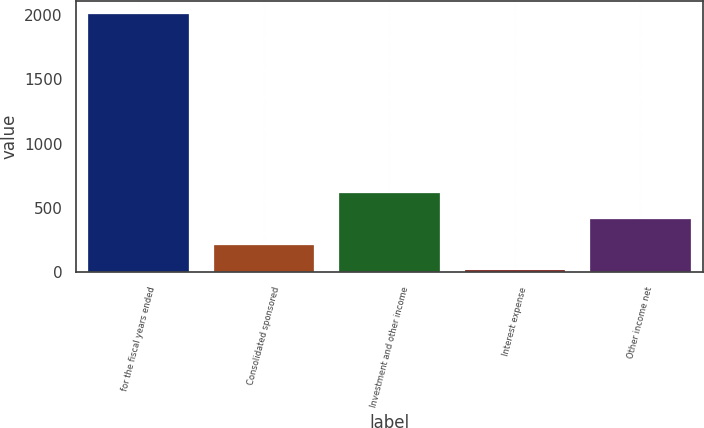Convert chart. <chart><loc_0><loc_0><loc_500><loc_500><bar_chart><fcel>for the fiscal years ended<fcel>Consolidated sponsored<fcel>Investment and other income<fcel>Interest expense<fcel>Other income net<nl><fcel>2008<fcel>215.02<fcel>613.46<fcel>15.8<fcel>414.24<nl></chart> 